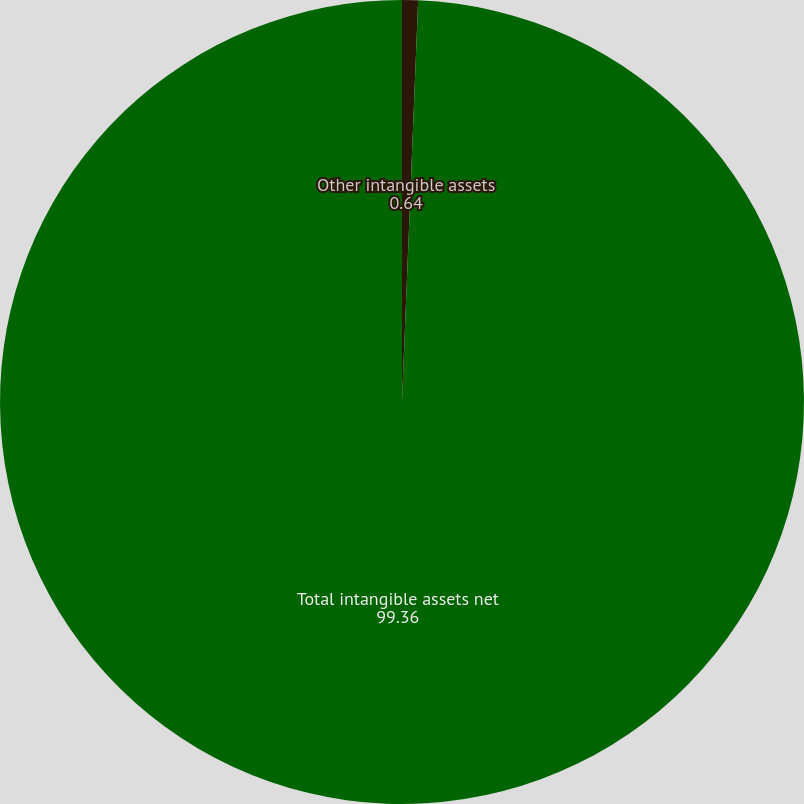Convert chart to OTSL. <chart><loc_0><loc_0><loc_500><loc_500><pie_chart><fcel>Other intangible assets<fcel>Total intangible assets net<nl><fcel>0.64%<fcel>99.36%<nl></chart> 